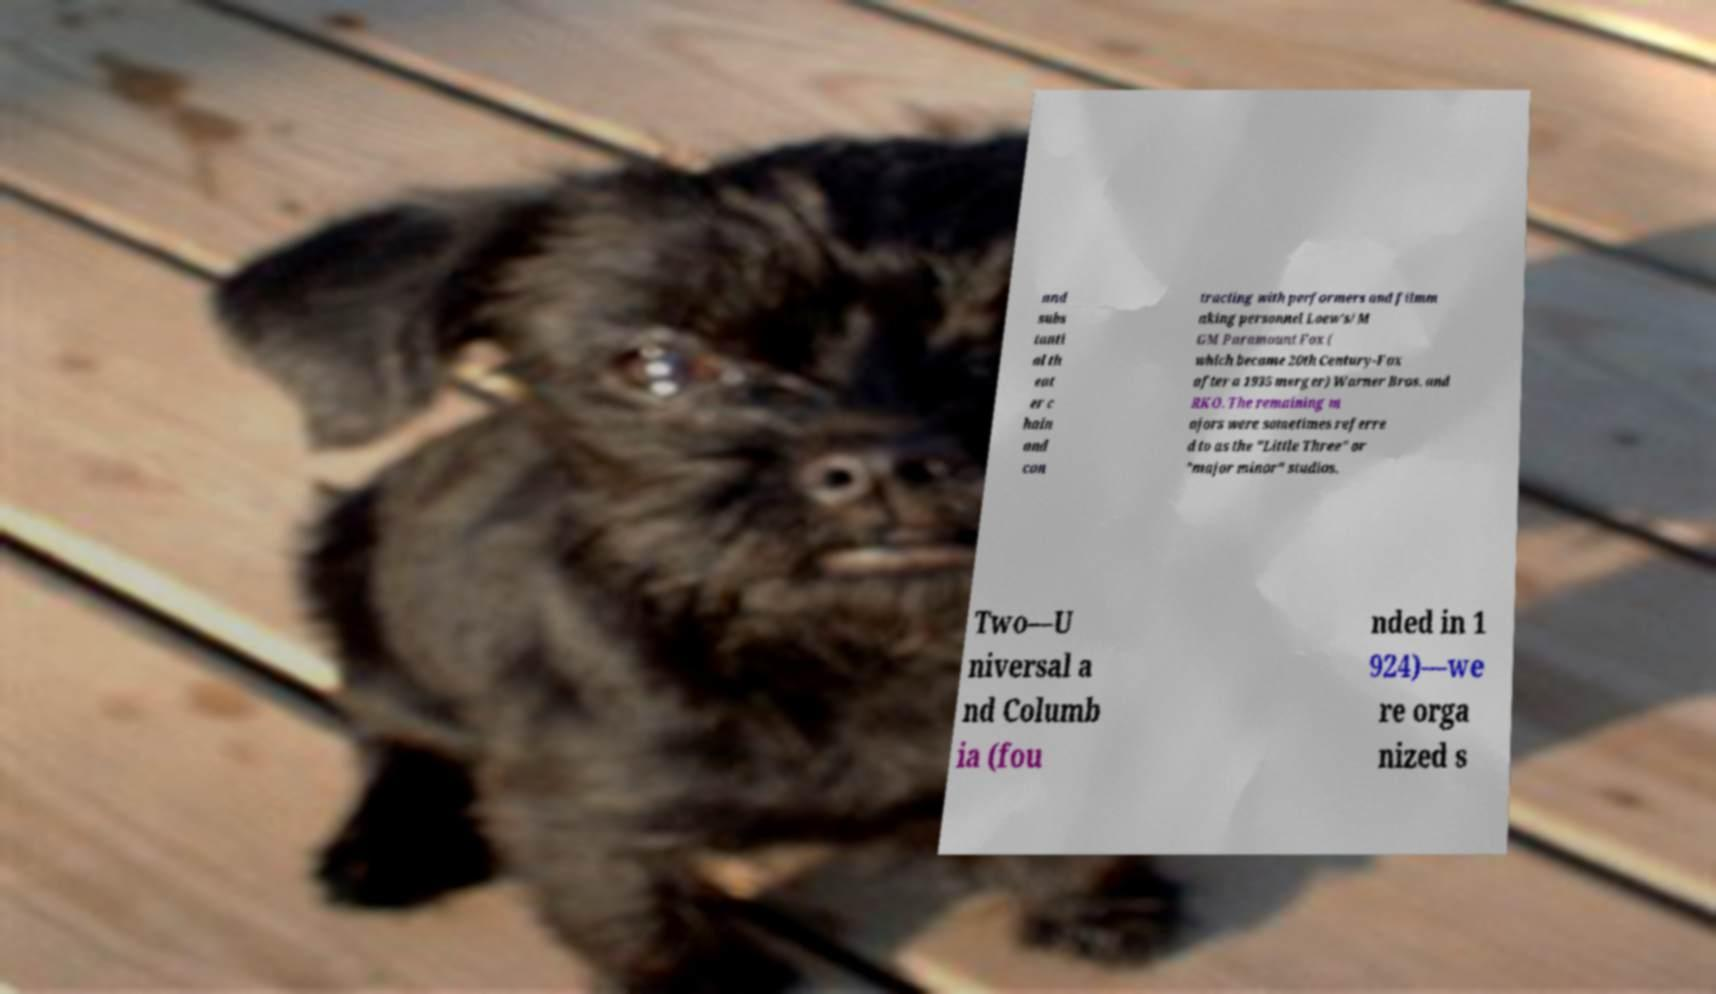Could you extract and type out the text from this image? and subs tanti al th eat er c hain and con tracting with performers and filmm aking personnel Loew's/M GM Paramount Fox ( which became 20th Century-Fox after a 1935 merger) Warner Bros. and RKO. The remaining m ajors were sometimes referre d to as the "Little Three" or "major minor" studios. Two—U niversal a nd Columb ia (fou nded in 1 924)—we re orga nized s 